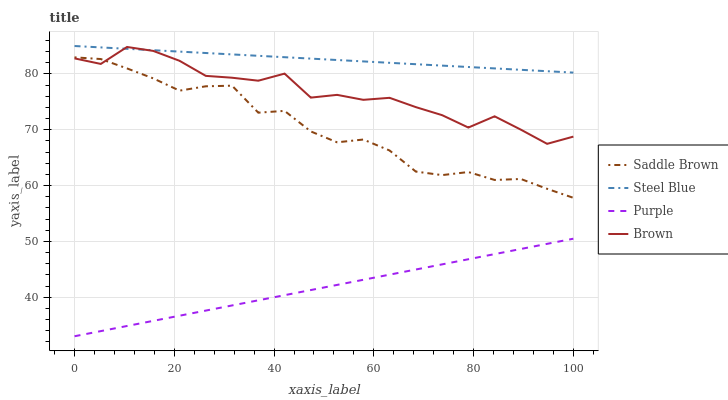Does Purple have the minimum area under the curve?
Answer yes or no. Yes. Does Steel Blue have the maximum area under the curve?
Answer yes or no. Yes. Does Brown have the minimum area under the curve?
Answer yes or no. No. Does Brown have the maximum area under the curve?
Answer yes or no. No. Is Purple the smoothest?
Answer yes or no. Yes. Is Brown the roughest?
Answer yes or no. Yes. Is Saddle Brown the smoothest?
Answer yes or no. No. Is Saddle Brown the roughest?
Answer yes or no. No. Does Purple have the lowest value?
Answer yes or no. Yes. Does Brown have the lowest value?
Answer yes or no. No. Does Steel Blue have the highest value?
Answer yes or no. Yes. Does Brown have the highest value?
Answer yes or no. No. Is Purple less than Brown?
Answer yes or no. Yes. Is Steel Blue greater than Saddle Brown?
Answer yes or no. Yes. Does Steel Blue intersect Brown?
Answer yes or no. Yes. Is Steel Blue less than Brown?
Answer yes or no. No. Is Steel Blue greater than Brown?
Answer yes or no. No. Does Purple intersect Brown?
Answer yes or no. No. 